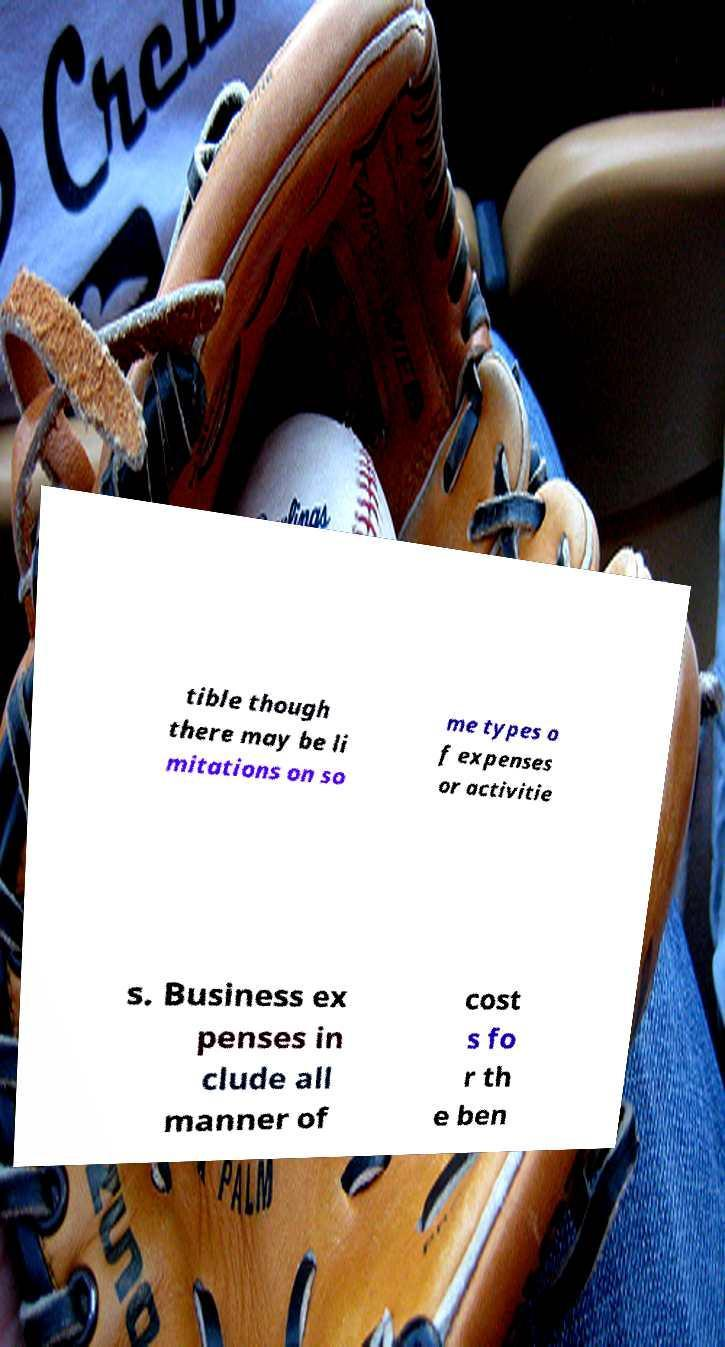For documentation purposes, I need the text within this image transcribed. Could you provide that? tible though there may be li mitations on so me types o f expenses or activitie s. Business ex penses in clude all manner of cost s fo r th e ben 